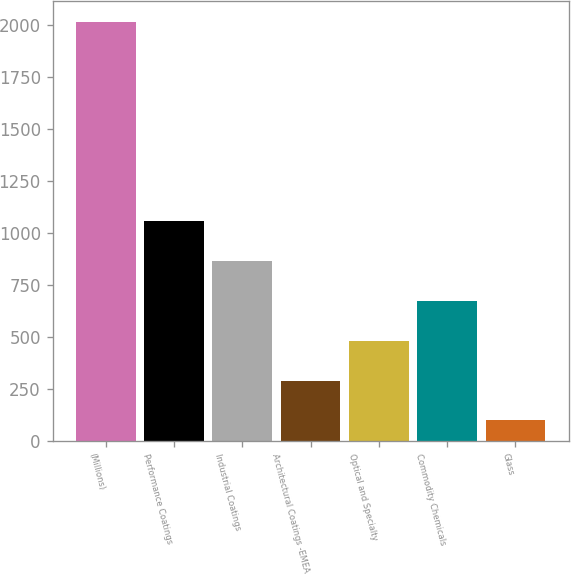<chart> <loc_0><loc_0><loc_500><loc_500><bar_chart><fcel>(Millions)<fcel>Performance Coatings<fcel>Industrial Coatings<fcel>Architectural Coatings -EMEA<fcel>Optical and Specialty<fcel>Commodity Chemicals<fcel>Glass<nl><fcel>2011<fcel>1054<fcel>862.6<fcel>288.4<fcel>479.8<fcel>671.2<fcel>97<nl></chart> 